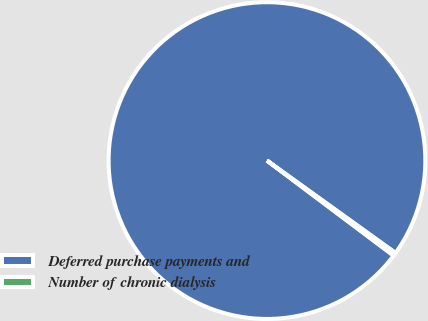Convert chart to OTSL. <chart><loc_0><loc_0><loc_500><loc_500><pie_chart><fcel>Deferred purchase payments and<fcel>Number of chronic dialysis<nl><fcel>99.67%<fcel>0.33%<nl></chart> 